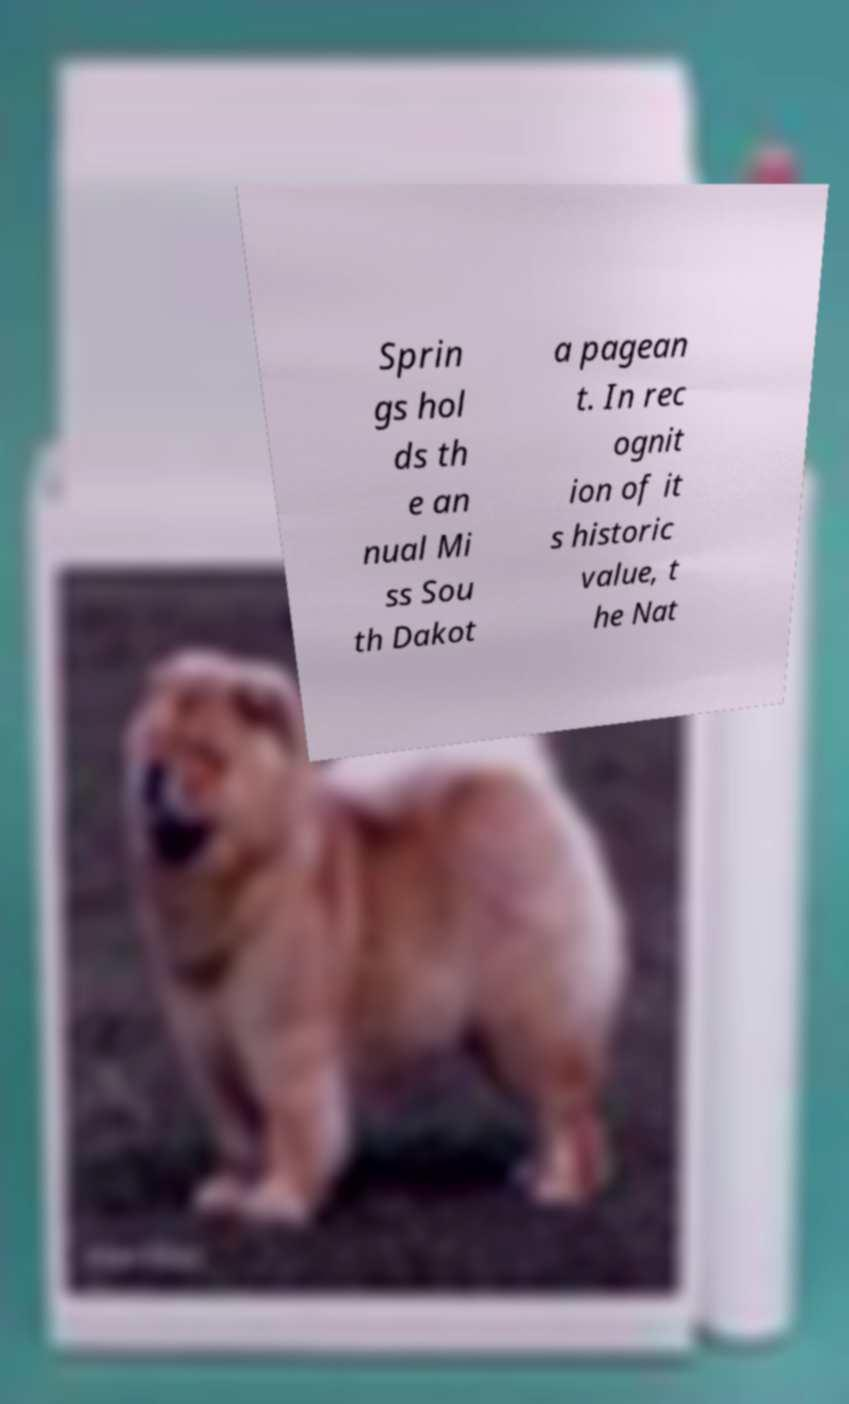What messages or text are displayed in this image? I need them in a readable, typed format. Sprin gs hol ds th e an nual Mi ss Sou th Dakot a pagean t. In rec ognit ion of it s historic value, t he Nat 